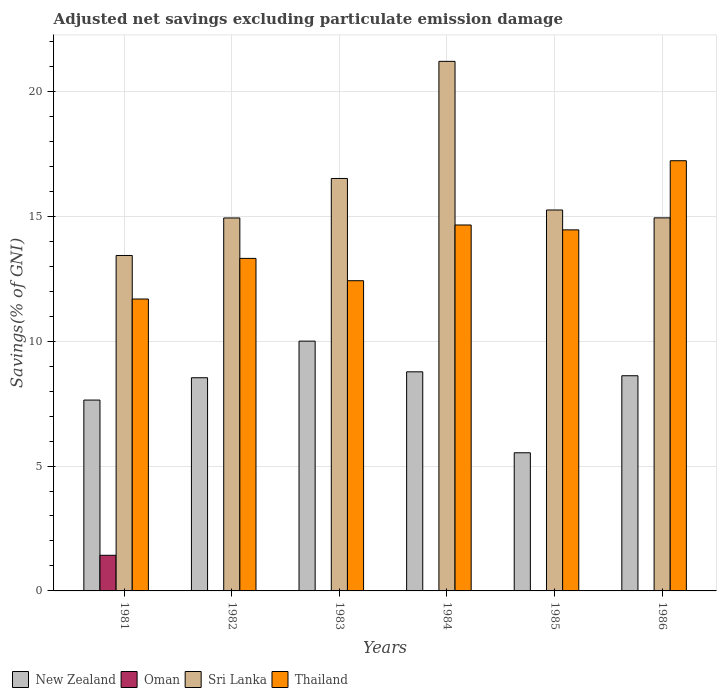How many different coloured bars are there?
Your answer should be very brief. 4. How many bars are there on the 1st tick from the right?
Your answer should be compact. 3. What is the label of the 5th group of bars from the left?
Provide a short and direct response. 1985. In how many cases, is the number of bars for a given year not equal to the number of legend labels?
Give a very brief answer. 4. What is the adjusted net savings in New Zealand in 1981?
Give a very brief answer. 7.64. Across all years, what is the maximum adjusted net savings in Sri Lanka?
Ensure brevity in your answer.  21.2. Across all years, what is the minimum adjusted net savings in New Zealand?
Give a very brief answer. 5.53. In which year was the adjusted net savings in Thailand maximum?
Your answer should be very brief. 1986. What is the total adjusted net savings in New Zealand in the graph?
Offer a terse response. 49.1. What is the difference between the adjusted net savings in New Zealand in 1981 and that in 1983?
Your answer should be very brief. -2.36. What is the difference between the adjusted net savings in Sri Lanka in 1981 and the adjusted net savings in Thailand in 1983?
Provide a short and direct response. 1.01. What is the average adjusted net savings in Sri Lanka per year?
Offer a terse response. 16.04. In the year 1983, what is the difference between the adjusted net savings in Sri Lanka and adjusted net savings in Thailand?
Your response must be concise. 4.09. What is the ratio of the adjusted net savings in Thailand in 1985 to that in 1986?
Your answer should be very brief. 0.84. Is the adjusted net savings in Thailand in 1981 less than that in 1985?
Provide a short and direct response. Yes. Is the difference between the adjusted net savings in Sri Lanka in 1983 and 1985 greater than the difference between the adjusted net savings in Thailand in 1983 and 1985?
Your answer should be very brief. Yes. What is the difference between the highest and the second highest adjusted net savings in Thailand?
Ensure brevity in your answer.  2.57. What is the difference between the highest and the lowest adjusted net savings in Sri Lanka?
Offer a terse response. 7.77. In how many years, is the adjusted net savings in Thailand greater than the average adjusted net savings in Thailand taken over all years?
Your answer should be very brief. 3. Is the sum of the adjusted net savings in New Zealand in 1982 and 1984 greater than the maximum adjusted net savings in Sri Lanka across all years?
Offer a terse response. No. Is it the case that in every year, the sum of the adjusted net savings in Thailand and adjusted net savings in New Zealand is greater than the sum of adjusted net savings in Oman and adjusted net savings in Sri Lanka?
Ensure brevity in your answer.  No. How many bars are there?
Your response must be concise. 20. Are all the bars in the graph horizontal?
Offer a terse response. No. Are the values on the major ticks of Y-axis written in scientific E-notation?
Your answer should be compact. No. Does the graph contain any zero values?
Provide a succinct answer. Yes. How are the legend labels stacked?
Make the answer very short. Horizontal. What is the title of the graph?
Provide a succinct answer. Adjusted net savings excluding particulate emission damage. What is the label or title of the X-axis?
Provide a short and direct response. Years. What is the label or title of the Y-axis?
Make the answer very short. Savings(% of GNI). What is the Savings(% of GNI) of New Zealand in 1981?
Your response must be concise. 7.64. What is the Savings(% of GNI) of Oman in 1981?
Your answer should be very brief. 1.43. What is the Savings(% of GNI) of Sri Lanka in 1981?
Provide a short and direct response. 13.43. What is the Savings(% of GNI) in Thailand in 1981?
Ensure brevity in your answer.  11.69. What is the Savings(% of GNI) of New Zealand in 1982?
Your answer should be compact. 8.54. What is the Savings(% of GNI) of Oman in 1982?
Offer a very short reply. 0. What is the Savings(% of GNI) in Sri Lanka in 1982?
Provide a short and direct response. 14.93. What is the Savings(% of GNI) in Thailand in 1982?
Ensure brevity in your answer.  13.31. What is the Savings(% of GNI) of New Zealand in 1983?
Provide a succinct answer. 10. What is the Savings(% of GNI) of Sri Lanka in 1983?
Your response must be concise. 16.51. What is the Savings(% of GNI) of Thailand in 1983?
Your answer should be compact. 12.42. What is the Savings(% of GNI) of New Zealand in 1984?
Offer a terse response. 8.77. What is the Savings(% of GNI) in Oman in 1984?
Give a very brief answer. 0.01. What is the Savings(% of GNI) of Sri Lanka in 1984?
Offer a very short reply. 21.2. What is the Savings(% of GNI) of Thailand in 1984?
Ensure brevity in your answer.  14.65. What is the Savings(% of GNI) of New Zealand in 1985?
Ensure brevity in your answer.  5.53. What is the Savings(% of GNI) in Oman in 1985?
Ensure brevity in your answer.  0. What is the Savings(% of GNI) in Sri Lanka in 1985?
Keep it short and to the point. 15.25. What is the Savings(% of GNI) in Thailand in 1985?
Provide a short and direct response. 14.46. What is the Savings(% of GNI) of New Zealand in 1986?
Make the answer very short. 8.62. What is the Savings(% of GNI) in Oman in 1986?
Make the answer very short. 0. What is the Savings(% of GNI) in Sri Lanka in 1986?
Provide a short and direct response. 14.94. What is the Savings(% of GNI) of Thailand in 1986?
Provide a short and direct response. 17.22. Across all years, what is the maximum Savings(% of GNI) in New Zealand?
Make the answer very short. 10. Across all years, what is the maximum Savings(% of GNI) of Oman?
Ensure brevity in your answer.  1.43. Across all years, what is the maximum Savings(% of GNI) of Sri Lanka?
Provide a succinct answer. 21.2. Across all years, what is the maximum Savings(% of GNI) in Thailand?
Keep it short and to the point. 17.22. Across all years, what is the minimum Savings(% of GNI) of New Zealand?
Offer a terse response. 5.53. Across all years, what is the minimum Savings(% of GNI) in Oman?
Keep it short and to the point. 0. Across all years, what is the minimum Savings(% of GNI) of Sri Lanka?
Give a very brief answer. 13.43. Across all years, what is the minimum Savings(% of GNI) of Thailand?
Give a very brief answer. 11.69. What is the total Savings(% of GNI) of New Zealand in the graph?
Your answer should be very brief. 49.1. What is the total Savings(% of GNI) of Oman in the graph?
Offer a terse response. 1.44. What is the total Savings(% of GNI) of Sri Lanka in the graph?
Provide a short and direct response. 96.27. What is the total Savings(% of GNI) of Thailand in the graph?
Provide a succinct answer. 83.75. What is the difference between the Savings(% of GNI) of New Zealand in 1981 and that in 1982?
Offer a very short reply. -0.89. What is the difference between the Savings(% of GNI) in Sri Lanka in 1981 and that in 1982?
Provide a succinct answer. -1.5. What is the difference between the Savings(% of GNI) of Thailand in 1981 and that in 1982?
Your answer should be compact. -1.63. What is the difference between the Savings(% of GNI) in New Zealand in 1981 and that in 1983?
Give a very brief answer. -2.36. What is the difference between the Savings(% of GNI) in Sri Lanka in 1981 and that in 1983?
Your answer should be compact. -3.08. What is the difference between the Savings(% of GNI) in Thailand in 1981 and that in 1983?
Offer a terse response. -0.73. What is the difference between the Savings(% of GNI) of New Zealand in 1981 and that in 1984?
Offer a terse response. -1.13. What is the difference between the Savings(% of GNI) of Oman in 1981 and that in 1984?
Offer a very short reply. 1.41. What is the difference between the Savings(% of GNI) in Sri Lanka in 1981 and that in 1984?
Your response must be concise. -7.77. What is the difference between the Savings(% of GNI) in Thailand in 1981 and that in 1984?
Provide a short and direct response. -2.96. What is the difference between the Savings(% of GNI) in New Zealand in 1981 and that in 1985?
Offer a very short reply. 2.11. What is the difference between the Savings(% of GNI) of Sri Lanka in 1981 and that in 1985?
Your answer should be compact. -1.82. What is the difference between the Savings(% of GNI) of Thailand in 1981 and that in 1985?
Offer a very short reply. -2.77. What is the difference between the Savings(% of GNI) of New Zealand in 1981 and that in 1986?
Your response must be concise. -0.97. What is the difference between the Savings(% of GNI) of Sri Lanka in 1981 and that in 1986?
Your response must be concise. -1.51. What is the difference between the Savings(% of GNI) in Thailand in 1981 and that in 1986?
Provide a succinct answer. -5.54. What is the difference between the Savings(% of GNI) in New Zealand in 1982 and that in 1983?
Provide a succinct answer. -1.47. What is the difference between the Savings(% of GNI) of Sri Lanka in 1982 and that in 1983?
Ensure brevity in your answer.  -1.58. What is the difference between the Savings(% of GNI) in Thailand in 1982 and that in 1983?
Offer a terse response. 0.89. What is the difference between the Savings(% of GNI) of New Zealand in 1982 and that in 1984?
Your answer should be compact. -0.24. What is the difference between the Savings(% of GNI) in Sri Lanka in 1982 and that in 1984?
Your response must be concise. -6.27. What is the difference between the Savings(% of GNI) in Thailand in 1982 and that in 1984?
Make the answer very short. -1.34. What is the difference between the Savings(% of GNI) of New Zealand in 1982 and that in 1985?
Your answer should be compact. 3. What is the difference between the Savings(% of GNI) in Sri Lanka in 1982 and that in 1985?
Offer a terse response. -0.32. What is the difference between the Savings(% of GNI) of Thailand in 1982 and that in 1985?
Provide a short and direct response. -1.14. What is the difference between the Savings(% of GNI) of New Zealand in 1982 and that in 1986?
Provide a succinct answer. -0.08. What is the difference between the Savings(% of GNI) of Sri Lanka in 1982 and that in 1986?
Provide a succinct answer. -0. What is the difference between the Savings(% of GNI) in Thailand in 1982 and that in 1986?
Provide a succinct answer. -3.91. What is the difference between the Savings(% of GNI) of New Zealand in 1983 and that in 1984?
Give a very brief answer. 1.23. What is the difference between the Savings(% of GNI) of Sri Lanka in 1983 and that in 1984?
Keep it short and to the point. -4.69. What is the difference between the Savings(% of GNI) in Thailand in 1983 and that in 1984?
Your answer should be compact. -2.23. What is the difference between the Savings(% of GNI) in New Zealand in 1983 and that in 1985?
Provide a succinct answer. 4.47. What is the difference between the Savings(% of GNI) of Sri Lanka in 1983 and that in 1985?
Provide a succinct answer. 1.26. What is the difference between the Savings(% of GNI) of Thailand in 1983 and that in 1985?
Keep it short and to the point. -2.04. What is the difference between the Savings(% of GNI) of New Zealand in 1983 and that in 1986?
Provide a succinct answer. 1.39. What is the difference between the Savings(% of GNI) in Sri Lanka in 1983 and that in 1986?
Keep it short and to the point. 1.58. What is the difference between the Savings(% of GNI) in Thailand in 1983 and that in 1986?
Your answer should be very brief. -4.8. What is the difference between the Savings(% of GNI) of New Zealand in 1984 and that in 1985?
Provide a short and direct response. 3.24. What is the difference between the Savings(% of GNI) of Sri Lanka in 1984 and that in 1985?
Make the answer very short. 5.95. What is the difference between the Savings(% of GNI) of Thailand in 1984 and that in 1985?
Make the answer very short. 0.2. What is the difference between the Savings(% of GNI) in New Zealand in 1984 and that in 1986?
Ensure brevity in your answer.  0.16. What is the difference between the Savings(% of GNI) in Sri Lanka in 1984 and that in 1986?
Provide a short and direct response. 6.27. What is the difference between the Savings(% of GNI) of Thailand in 1984 and that in 1986?
Ensure brevity in your answer.  -2.57. What is the difference between the Savings(% of GNI) in New Zealand in 1985 and that in 1986?
Provide a succinct answer. -3.08. What is the difference between the Savings(% of GNI) in Sri Lanka in 1985 and that in 1986?
Provide a short and direct response. 0.32. What is the difference between the Savings(% of GNI) of Thailand in 1985 and that in 1986?
Provide a short and direct response. -2.77. What is the difference between the Savings(% of GNI) of New Zealand in 1981 and the Savings(% of GNI) of Sri Lanka in 1982?
Your response must be concise. -7.29. What is the difference between the Savings(% of GNI) of New Zealand in 1981 and the Savings(% of GNI) of Thailand in 1982?
Give a very brief answer. -5.67. What is the difference between the Savings(% of GNI) in Oman in 1981 and the Savings(% of GNI) in Sri Lanka in 1982?
Give a very brief answer. -13.51. What is the difference between the Savings(% of GNI) in Oman in 1981 and the Savings(% of GNI) in Thailand in 1982?
Provide a short and direct response. -11.89. What is the difference between the Savings(% of GNI) of Sri Lanka in 1981 and the Savings(% of GNI) of Thailand in 1982?
Your answer should be compact. 0.12. What is the difference between the Savings(% of GNI) of New Zealand in 1981 and the Savings(% of GNI) of Sri Lanka in 1983?
Your answer should be compact. -8.87. What is the difference between the Savings(% of GNI) in New Zealand in 1981 and the Savings(% of GNI) in Thailand in 1983?
Provide a short and direct response. -4.78. What is the difference between the Savings(% of GNI) of Oman in 1981 and the Savings(% of GNI) of Sri Lanka in 1983?
Give a very brief answer. -15.09. What is the difference between the Savings(% of GNI) in Oman in 1981 and the Savings(% of GNI) in Thailand in 1983?
Your answer should be very brief. -10.99. What is the difference between the Savings(% of GNI) of Sri Lanka in 1981 and the Savings(% of GNI) of Thailand in 1983?
Your response must be concise. 1.01. What is the difference between the Savings(% of GNI) in New Zealand in 1981 and the Savings(% of GNI) in Oman in 1984?
Your answer should be compact. 7.63. What is the difference between the Savings(% of GNI) in New Zealand in 1981 and the Savings(% of GNI) in Sri Lanka in 1984?
Give a very brief answer. -13.56. What is the difference between the Savings(% of GNI) in New Zealand in 1981 and the Savings(% of GNI) in Thailand in 1984?
Keep it short and to the point. -7.01. What is the difference between the Savings(% of GNI) of Oman in 1981 and the Savings(% of GNI) of Sri Lanka in 1984?
Offer a terse response. -19.78. What is the difference between the Savings(% of GNI) of Oman in 1981 and the Savings(% of GNI) of Thailand in 1984?
Your response must be concise. -13.22. What is the difference between the Savings(% of GNI) of Sri Lanka in 1981 and the Savings(% of GNI) of Thailand in 1984?
Offer a terse response. -1.22. What is the difference between the Savings(% of GNI) in New Zealand in 1981 and the Savings(% of GNI) in Sri Lanka in 1985?
Offer a terse response. -7.61. What is the difference between the Savings(% of GNI) in New Zealand in 1981 and the Savings(% of GNI) in Thailand in 1985?
Make the answer very short. -6.81. What is the difference between the Savings(% of GNI) in Oman in 1981 and the Savings(% of GNI) in Sri Lanka in 1985?
Your response must be concise. -13.83. What is the difference between the Savings(% of GNI) in Oman in 1981 and the Savings(% of GNI) in Thailand in 1985?
Your answer should be very brief. -13.03. What is the difference between the Savings(% of GNI) of Sri Lanka in 1981 and the Savings(% of GNI) of Thailand in 1985?
Make the answer very short. -1.02. What is the difference between the Savings(% of GNI) of New Zealand in 1981 and the Savings(% of GNI) of Sri Lanka in 1986?
Keep it short and to the point. -7.3. What is the difference between the Savings(% of GNI) of New Zealand in 1981 and the Savings(% of GNI) of Thailand in 1986?
Offer a terse response. -9.58. What is the difference between the Savings(% of GNI) in Oman in 1981 and the Savings(% of GNI) in Sri Lanka in 1986?
Ensure brevity in your answer.  -13.51. What is the difference between the Savings(% of GNI) of Oman in 1981 and the Savings(% of GNI) of Thailand in 1986?
Provide a succinct answer. -15.8. What is the difference between the Savings(% of GNI) in Sri Lanka in 1981 and the Savings(% of GNI) in Thailand in 1986?
Your answer should be compact. -3.79. What is the difference between the Savings(% of GNI) of New Zealand in 1982 and the Savings(% of GNI) of Sri Lanka in 1983?
Provide a succinct answer. -7.98. What is the difference between the Savings(% of GNI) in New Zealand in 1982 and the Savings(% of GNI) in Thailand in 1983?
Keep it short and to the point. -3.88. What is the difference between the Savings(% of GNI) in Sri Lanka in 1982 and the Savings(% of GNI) in Thailand in 1983?
Provide a short and direct response. 2.51. What is the difference between the Savings(% of GNI) of New Zealand in 1982 and the Savings(% of GNI) of Oman in 1984?
Provide a succinct answer. 8.52. What is the difference between the Savings(% of GNI) of New Zealand in 1982 and the Savings(% of GNI) of Sri Lanka in 1984?
Provide a succinct answer. -12.67. What is the difference between the Savings(% of GNI) of New Zealand in 1982 and the Savings(% of GNI) of Thailand in 1984?
Give a very brief answer. -6.12. What is the difference between the Savings(% of GNI) of Sri Lanka in 1982 and the Savings(% of GNI) of Thailand in 1984?
Keep it short and to the point. 0.28. What is the difference between the Savings(% of GNI) in New Zealand in 1982 and the Savings(% of GNI) in Sri Lanka in 1985?
Your response must be concise. -6.72. What is the difference between the Savings(% of GNI) in New Zealand in 1982 and the Savings(% of GNI) in Thailand in 1985?
Your answer should be compact. -5.92. What is the difference between the Savings(% of GNI) of Sri Lanka in 1982 and the Savings(% of GNI) of Thailand in 1985?
Your answer should be compact. 0.48. What is the difference between the Savings(% of GNI) in New Zealand in 1982 and the Savings(% of GNI) in Sri Lanka in 1986?
Keep it short and to the point. -6.4. What is the difference between the Savings(% of GNI) of New Zealand in 1982 and the Savings(% of GNI) of Thailand in 1986?
Offer a very short reply. -8.69. What is the difference between the Savings(% of GNI) in Sri Lanka in 1982 and the Savings(% of GNI) in Thailand in 1986?
Make the answer very short. -2.29. What is the difference between the Savings(% of GNI) of New Zealand in 1983 and the Savings(% of GNI) of Oman in 1984?
Your response must be concise. 9.99. What is the difference between the Savings(% of GNI) of New Zealand in 1983 and the Savings(% of GNI) of Sri Lanka in 1984?
Provide a succinct answer. -11.2. What is the difference between the Savings(% of GNI) of New Zealand in 1983 and the Savings(% of GNI) of Thailand in 1984?
Your answer should be compact. -4.65. What is the difference between the Savings(% of GNI) of Sri Lanka in 1983 and the Savings(% of GNI) of Thailand in 1984?
Make the answer very short. 1.86. What is the difference between the Savings(% of GNI) in New Zealand in 1983 and the Savings(% of GNI) in Sri Lanka in 1985?
Give a very brief answer. -5.25. What is the difference between the Savings(% of GNI) in New Zealand in 1983 and the Savings(% of GNI) in Thailand in 1985?
Offer a terse response. -4.45. What is the difference between the Savings(% of GNI) of Sri Lanka in 1983 and the Savings(% of GNI) of Thailand in 1985?
Offer a very short reply. 2.06. What is the difference between the Savings(% of GNI) of New Zealand in 1983 and the Savings(% of GNI) of Sri Lanka in 1986?
Your answer should be compact. -4.94. What is the difference between the Savings(% of GNI) in New Zealand in 1983 and the Savings(% of GNI) in Thailand in 1986?
Ensure brevity in your answer.  -7.22. What is the difference between the Savings(% of GNI) of Sri Lanka in 1983 and the Savings(% of GNI) of Thailand in 1986?
Make the answer very short. -0.71. What is the difference between the Savings(% of GNI) in New Zealand in 1984 and the Savings(% of GNI) in Sri Lanka in 1985?
Offer a terse response. -6.48. What is the difference between the Savings(% of GNI) in New Zealand in 1984 and the Savings(% of GNI) in Thailand in 1985?
Offer a very short reply. -5.68. What is the difference between the Savings(% of GNI) in Oman in 1984 and the Savings(% of GNI) in Sri Lanka in 1985?
Your answer should be compact. -15.24. What is the difference between the Savings(% of GNI) in Oman in 1984 and the Savings(% of GNI) in Thailand in 1985?
Your response must be concise. -14.44. What is the difference between the Savings(% of GNI) of Sri Lanka in 1984 and the Savings(% of GNI) of Thailand in 1985?
Your response must be concise. 6.75. What is the difference between the Savings(% of GNI) in New Zealand in 1984 and the Savings(% of GNI) in Sri Lanka in 1986?
Offer a terse response. -6.16. What is the difference between the Savings(% of GNI) of New Zealand in 1984 and the Savings(% of GNI) of Thailand in 1986?
Your answer should be compact. -8.45. What is the difference between the Savings(% of GNI) in Oman in 1984 and the Savings(% of GNI) in Sri Lanka in 1986?
Give a very brief answer. -14.92. What is the difference between the Savings(% of GNI) of Oman in 1984 and the Savings(% of GNI) of Thailand in 1986?
Offer a very short reply. -17.21. What is the difference between the Savings(% of GNI) of Sri Lanka in 1984 and the Savings(% of GNI) of Thailand in 1986?
Your answer should be compact. 3.98. What is the difference between the Savings(% of GNI) of New Zealand in 1985 and the Savings(% of GNI) of Sri Lanka in 1986?
Ensure brevity in your answer.  -9.41. What is the difference between the Savings(% of GNI) in New Zealand in 1985 and the Savings(% of GNI) in Thailand in 1986?
Ensure brevity in your answer.  -11.69. What is the difference between the Savings(% of GNI) in Sri Lanka in 1985 and the Savings(% of GNI) in Thailand in 1986?
Your answer should be very brief. -1.97. What is the average Savings(% of GNI) in New Zealand per year?
Make the answer very short. 8.18. What is the average Savings(% of GNI) of Oman per year?
Your answer should be compact. 0.24. What is the average Savings(% of GNI) of Sri Lanka per year?
Provide a short and direct response. 16.04. What is the average Savings(% of GNI) of Thailand per year?
Your answer should be very brief. 13.96. In the year 1981, what is the difference between the Savings(% of GNI) in New Zealand and Savings(% of GNI) in Oman?
Offer a very short reply. 6.21. In the year 1981, what is the difference between the Savings(% of GNI) in New Zealand and Savings(% of GNI) in Sri Lanka?
Provide a succinct answer. -5.79. In the year 1981, what is the difference between the Savings(% of GNI) of New Zealand and Savings(% of GNI) of Thailand?
Offer a very short reply. -4.05. In the year 1981, what is the difference between the Savings(% of GNI) of Oman and Savings(% of GNI) of Sri Lanka?
Provide a short and direct response. -12. In the year 1981, what is the difference between the Savings(% of GNI) of Oman and Savings(% of GNI) of Thailand?
Offer a very short reply. -10.26. In the year 1981, what is the difference between the Savings(% of GNI) in Sri Lanka and Savings(% of GNI) in Thailand?
Your answer should be compact. 1.74. In the year 1982, what is the difference between the Savings(% of GNI) in New Zealand and Savings(% of GNI) in Sri Lanka?
Your answer should be compact. -6.4. In the year 1982, what is the difference between the Savings(% of GNI) of New Zealand and Savings(% of GNI) of Thailand?
Give a very brief answer. -4.78. In the year 1982, what is the difference between the Savings(% of GNI) in Sri Lanka and Savings(% of GNI) in Thailand?
Give a very brief answer. 1.62. In the year 1983, what is the difference between the Savings(% of GNI) in New Zealand and Savings(% of GNI) in Sri Lanka?
Your answer should be very brief. -6.51. In the year 1983, what is the difference between the Savings(% of GNI) in New Zealand and Savings(% of GNI) in Thailand?
Ensure brevity in your answer.  -2.42. In the year 1983, what is the difference between the Savings(% of GNI) of Sri Lanka and Savings(% of GNI) of Thailand?
Offer a terse response. 4.09. In the year 1984, what is the difference between the Savings(% of GNI) of New Zealand and Savings(% of GNI) of Oman?
Your answer should be very brief. 8.76. In the year 1984, what is the difference between the Savings(% of GNI) of New Zealand and Savings(% of GNI) of Sri Lanka?
Keep it short and to the point. -12.43. In the year 1984, what is the difference between the Savings(% of GNI) in New Zealand and Savings(% of GNI) in Thailand?
Your answer should be very brief. -5.88. In the year 1984, what is the difference between the Savings(% of GNI) of Oman and Savings(% of GNI) of Sri Lanka?
Your response must be concise. -21.19. In the year 1984, what is the difference between the Savings(% of GNI) of Oman and Savings(% of GNI) of Thailand?
Provide a succinct answer. -14.64. In the year 1984, what is the difference between the Savings(% of GNI) of Sri Lanka and Savings(% of GNI) of Thailand?
Your answer should be compact. 6.55. In the year 1985, what is the difference between the Savings(% of GNI) in New Zealand and Savings(% of GNI) in Sri Lanka?
Your answer should be compact. -9.72. In the year 1985, what is the difference between the Savings(% of GNI) of New Zealand and Savings(% of GNI) of Thailand?
Offer a very short reply. -8.92. In the year 1985, what is the difference between the Savings(% of GNI) in Sri Lanka and Savings(% of GNI) in Thailand?
Ensure brevity in your answer.  0.8. In the year 1986, what is the difference between the Savings(% of GNI) in New Zealand and Savings(% of GNI) in Sri Lanka?
Offer a very short reply. -6.32. In the year 1986, what is the difference between the Savings(% of GNI) in New Zealand and Savings(% of GNI) in Thailand?
Keep it short and to the point. -8.61. In the year 1986, what is the difference between the Savings(% of GNI) of Sri Lanka and Savings(% of GNI) of Thailand?
Your answer should be very brief. -2.29. What is the ratio of the Savings(% of GNI) in New Zealand in 1981 to that in 1982?
Give a very brief answer. 0.9. What is the ratio of the Savings(% of GNI) of Sri Lanka in 1981 to that in 1982?
Provide a succinct answer. 0.9. What is the ratio of the Savings(% of GNI) of Thailand in 1981 to that in 1982?
Give a very brief answer. 0.88. What is the ratio of the Savings(% of GNI) in New Zealand in 1981 to that in 1983?
Make the answer very short. 0.76. What is the ratio of the Savings(% of GNI) of Sri Lanka in 1981 to that in 1983?
Offer a terse response. 0.81. What is the ratio of the Savings(% of GNI) of Thailand in 1981 to that in 1983?
Keep it short and to the point. 0.94. What is the ratio of the Savings(% of GNI) in New Zealand in 1981 to that in 1984?
Your answer should be compact. 0.87. What is the ratio of the Savings(% of GNI) of Oman in 1981 to that in 1984?
Your response must be concise. 99.49. What is the ratio of the Savings(% of GNI) in Sri Lanka in 1981 to that in 1984?
Your answer should be very brief. 0.63. What is the ratio of the Savings(% of GNI) of Thailand in 1981 to that in 1984?
Give a very brief answer. 0.8. What is the ratio of the Savings(% of GNI) in New Zealand in 1981 to that in 1985?
Provide a short and direct response. 1.38. What is the ratio of the Savings(% of GNI) in Sri Lanka in 1981 to that in 1985?
Give a very brief answer. 0.88. What is the ratio of the Savings(% of GNI) in Thailand in 1981 to that in 1985?
Your answer should be compact. 0.81. What is the ratio of the Savings(% of GNI) in New Zealand in 1981 to that in 1986?
Keep it short and to the point. 0.89. What is the ratio of the Savings(% of GNI) of Sri Lanka in 1981 to that in 1986?
Your answer should be compact. 0.9. What is the ratio of the Savings(% of GNI) in Thailand in 1981 to that in 1986?
Your response must be concise. 0.68. What is the ratio of the Savings(% of GNI) of New Zealand in 1982 to that in 1983?
Provide a succinct answer. 0.85. What is the ratio of the Savings(% of GNI) of Sri Lanka in 1982 to that in 1983?
Provide a short and direct response. 0.9. What is the ratio of the Savings(% of GNI) of Thailand in 1982 to that in 1983?
Your response must be concise. 1.07. What is the ratio of the Savings(% of GNI) in Sri Lanka in 1982 to that in 1984?
Keep it short and to the point. 0.7. What is the ratio of the Savings(% of GNI) in Thailand in 1982 to that in 1984?
Your answer should be very brief. 0.91. What is the ratio of the Savings(% of GNI) in New Zealand in 1982 to that in 1985?
Offer a terse response. 1.54. What is the ratio of the Savings(% of GNI) in Sri Lanka in 1982 to that in 1985?
Your response must be concise. 0.98. What is the ratio of the Savings(% of GNI) in Thailand in 1982 to that in 1985?
Keep it short and to the point. 0.92. What is the ratio of the Savings(% of GNI) in New Zealand in 1982 to that in 1986?
Offer a terse response. 0.99. What is the ratio of the Savings(% of GNI) in Sri Lanka in 1982 to that in 1986?
Your answer should be very brief. 1. What is the ratio of the Savings(% of GNI) of Thailand in 1982 to that in 1986?
Your answer should be compact. 0.77. What is the ratio of the Savings(% of GNI) of New Zealand in 1983 to that in 1984?
Give a very brief answer. 1.14. What is the ratio of the Savings(% of GNI) in Sri Lanka in 1983 to that in 1984?
Your response must be concise. 0.78. What is the ratio of the Savings(% of GNI) of Thailand in 1983 to that in 1984?
Provide a short and direct response. 0.85. What is the ratio of the Savings(% of GNI) in New Zealand in 1983 to that in 1985?
Ensure brevity in your answer.  1.81. What is the ratio of the Savings(% of GNI) of Sri Lanka in 1983 to that in 1985?
Provide a succinct answer. 1.08. What is the ratio of the Savings(% of GNI) in Thailand in 1983 to that in 1985?
Keep it short and to the point. 0.86. What is the ratio of the Savings(% of GNI) in New Zealand in 1983 to that in 1986?
Your answer should be compact. 1.16. What is the ratio of the Savings(% of GNI) of Sri Lanka in 1983 to that in 1986?
Provide a short and direct response. 1.11. What is the ratio of the Savings(% of GNI) in Thailand in 1983 to that in 1986?
Ensure brevity in your answer.  0.72. What is the ratio of the Savings(% of GNI) in New Zealand in 1984 to that in 1985?
Provide a short and direct response. 1.59. What is the ratio of the Savings(% of GNI) of Sri Lanka in 1984 to that in 1985?
Provide a short and direct response. 1.39. What is the ratio of the Savings(% of GNI) in Thailand in 1984 to that in 1985?
Provide a short and direct response. 1.01. What is the ratio of the Savings(% of GNI) of New Zealand in 1984 to that in 1986?
Ensure brevity in your answer.  1.02. What is the ratio of the Savings(% of GNI) in Sri Lanka in 1984 to that in 1986?
Your answer should be very brief. 1.42. What is the ratio of the Savings(% of GNI) in Thailand in 1984 to that in 1986?
Give a very brief answer. 0.85. What is the ratio of the Savings(% of GNI) in New Zealand in 1985 to that in 1986?
Offer a terse response. 0.64. What is the ratio of the Savings(% of GNI) in Sri Lanka in 1985 to that in 1986?
Give a very brief answer. 1.02. What is the ratio of the Savings(% of GNI) of Thailand in 1985 to that in 1986?
Give a very brief answer. 0.84. What is the difference between the highest and the second highest Savings(% of GNI) in New Zealand?
Your answer should be compact. 1.23. What is the difference between the highest and the second highest Savings(% of GNI) of Sri Lanka?
Give a very brief answer. 4.69. What is the difference between the highest and the second highest Savings(% of GNI) in Thailand?
Ensure brevity in your answer.  2.57. What is the difference between the highest and the lowest Savings(% of GNI) in New Zealand?
Your answer should be very brief. 4.47. What is the difference between the highest and the lowest Savings(% of GNI) in Oman?
Your answer should be compact. 1.43. What is the difference between the highest and the lowest Savings(% of GNI) in Sri Lanka?
Ensure brevity in your answer.  7.77. What is the difference between the highest and the lowest Savings(% of GNI) of Thailand?
Your answer should be compact. 5.54. 